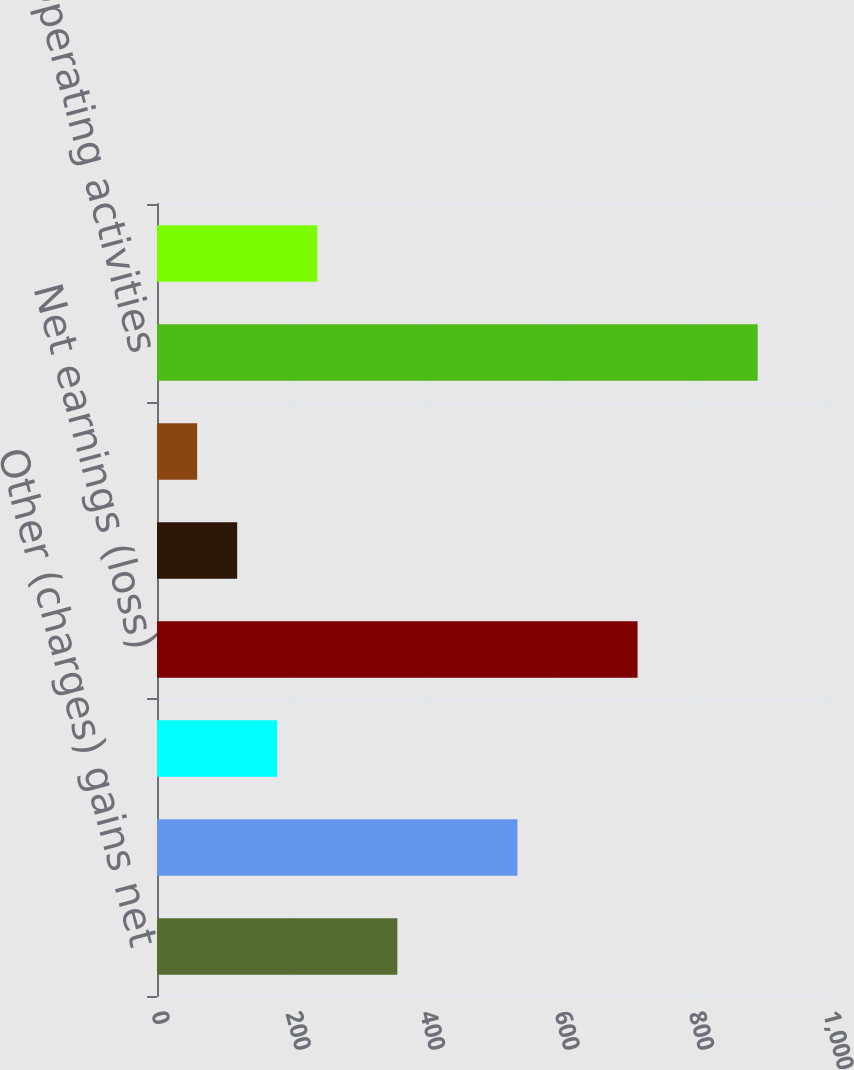<chart> <loc_0><loc_0><loc_500><loc_500><bar_chart><fcel>Other (charges) gains net<fcel>Operating profit<fcel>Earnings (loss) from<fcel>Net earnings (loss)<fcel>Continuing operations - basic<fcel>Continuing operations -<fcel>Operating activities<fcel>Investing activities<nl><fcel>357.64<fcel>536.38<fcel>178.9<fcel>715.12<fcel>119.32<fcel>59.74<fcel>893.86<fcel>238.48<nl></chart> 